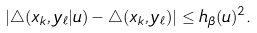<formula> <loc_0><loc_0><loc_500><loc_500>\left | \triangle ( { x } _ { k } , { y } _ { \ell } | u ) - \triangle ( { x } _ { k } , { y } _ { \ell } ) \right | \leq h _ { \beta } ( u ) ^ { 2 } .</formula> 